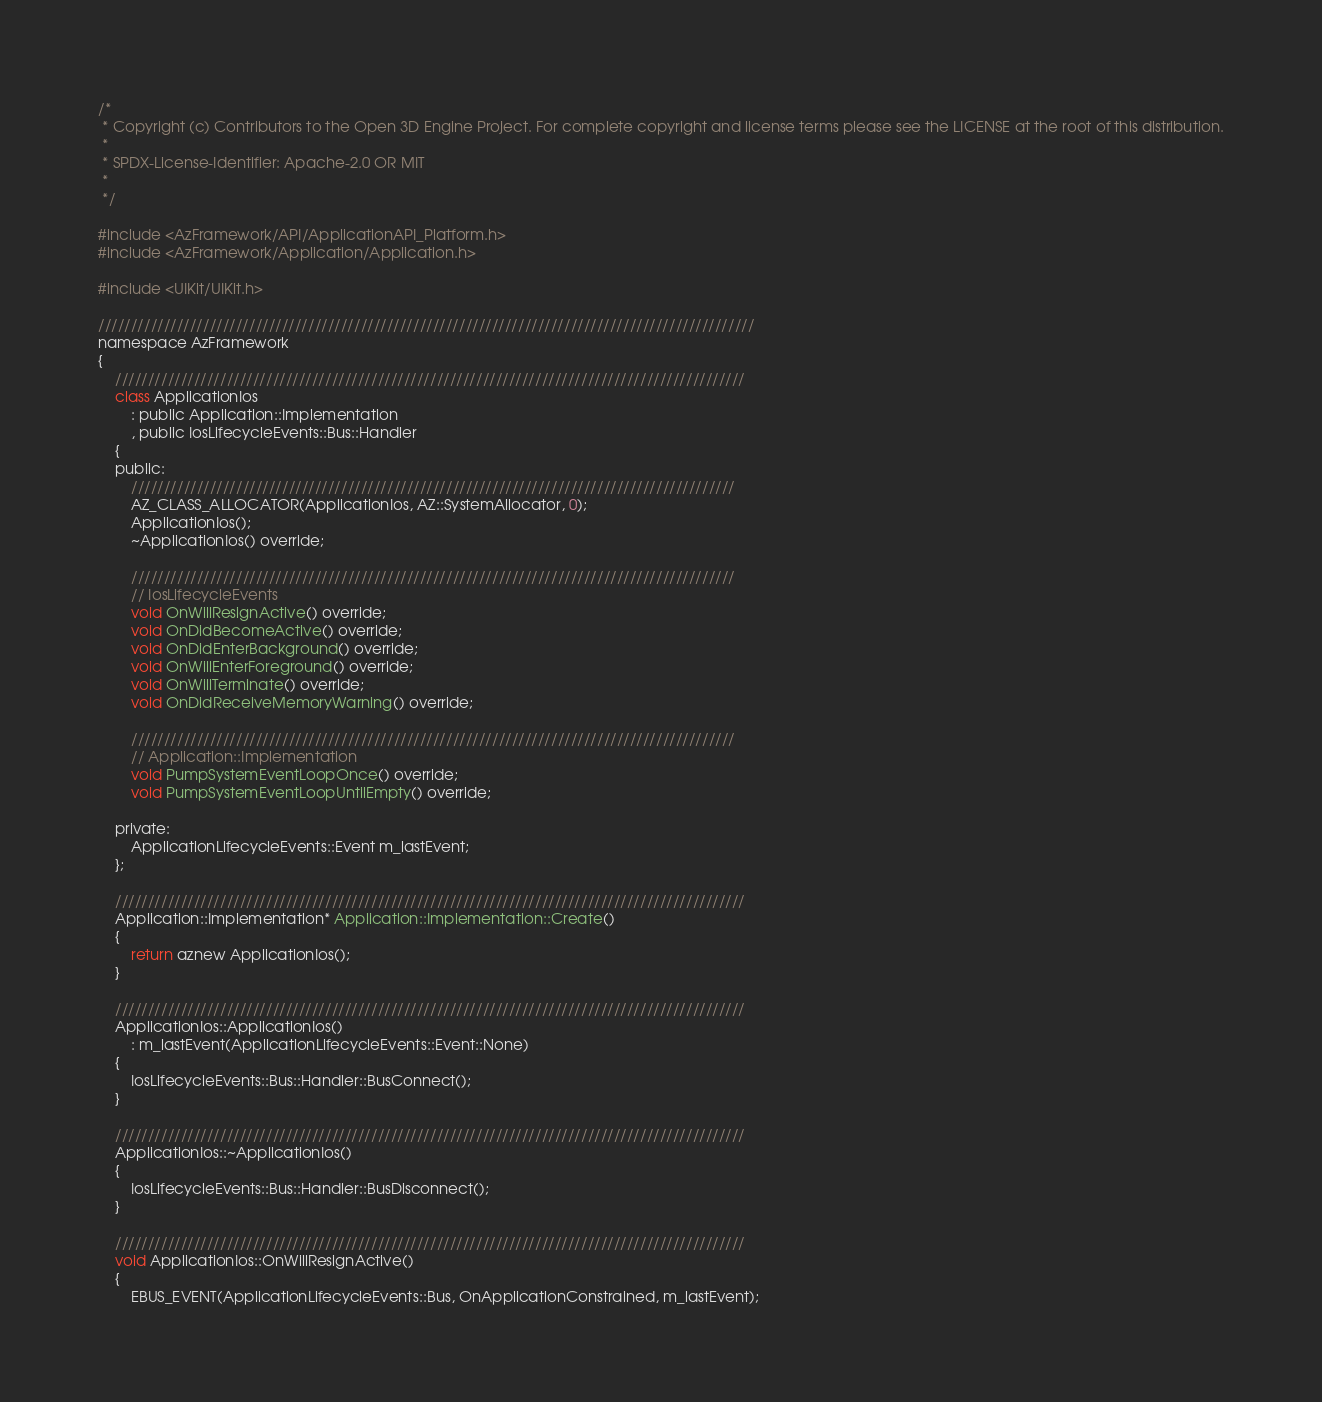<code> <loc_0><loc_0><loc_500><loc_500><_ObjectiveC_>/*
 * Copyright (c) Contributors to the Open 3D Engine Project. For complete copyright and license terms please see the LICENSE at the root of this distribution.
 * 
 * SPDX-License-Identifier: Apache-2.0 OR MIT
 *
 */

#include <AzFramework/API/ApplicationAPI_Platform.h>
#include <AzFramework/Application/Application.h>

#include <UIKit/UIKit.h>

////////////////////////////////////////////////////////////////////////////////////////////////////
namespace AzFramework
{
    ////////////////////////////////////////////////////////////////////////////////////////////////
    class ApplicationIos
        : public Application::Implementation
        , public IosLifecycleEvents::Bus::Handler
    {
    public:
        ////////////////////////////////////////////////////////////////////////////////////////////
        AZ_CLASS_ALLOCATOR(ApplicationIos, AZ::SystemAllocator, 0);
        ApplicationIos();
        ~ApplicationIos() override;

        ////////////////////////////////////////////////////////////////////////////////////////////
        // IosLifecycleEvents
        void OnWillResignActive() override;
        void OnDidBecomeActive() override;
        void OnDidEnterBackground() override;
        void OnWillEnterForeground() override;
        void OnWillTerminate() override;
        void OnDidReceiveMemoryWarning() override;

        ////////////////////////////////////////////////////////////////////////////////////////////
        // Application::Implementation
        void PumpSystemEventLoopOnce() override;
        void PumpSystemEventLoopUntilEmpty() override;

    private:
        ApplicationLifecycleEvents::Event m_lastEvent;
    };

    ////////////////////////////////////////////////////////////////////////////////////////////////
    Application::Implementation* Application::Implementation::Create()
    {
        return aznew ApplicationIos();
    }

    ////////////////////////////////////////////////////////////////////////////////////////////////
    ApplicationIos::ApplicationIos()
        : m_lastEvent(ApplicationLifecycleEvents::Event::None)
    {
        IosLifecycleEvents::Bus::Handler::BusConnect();
    }

    ////////////////////////////////////////////////////////////////////////////////////////////////
    ApplicationIos::~ApplicationIos()
    {
        IosLifecycleEvents::Bus::Handler::BusDisconnect();
    }

    ////////////////////////////////////////////////////////////////////////////////////////////////
    void ApplicationIos::OnWillResignActive()
    {
        EBUS_EVENT(ApplicationLifecycleEvents::Bus, OnApplicationConstrained, m_lastEvent);</code> 